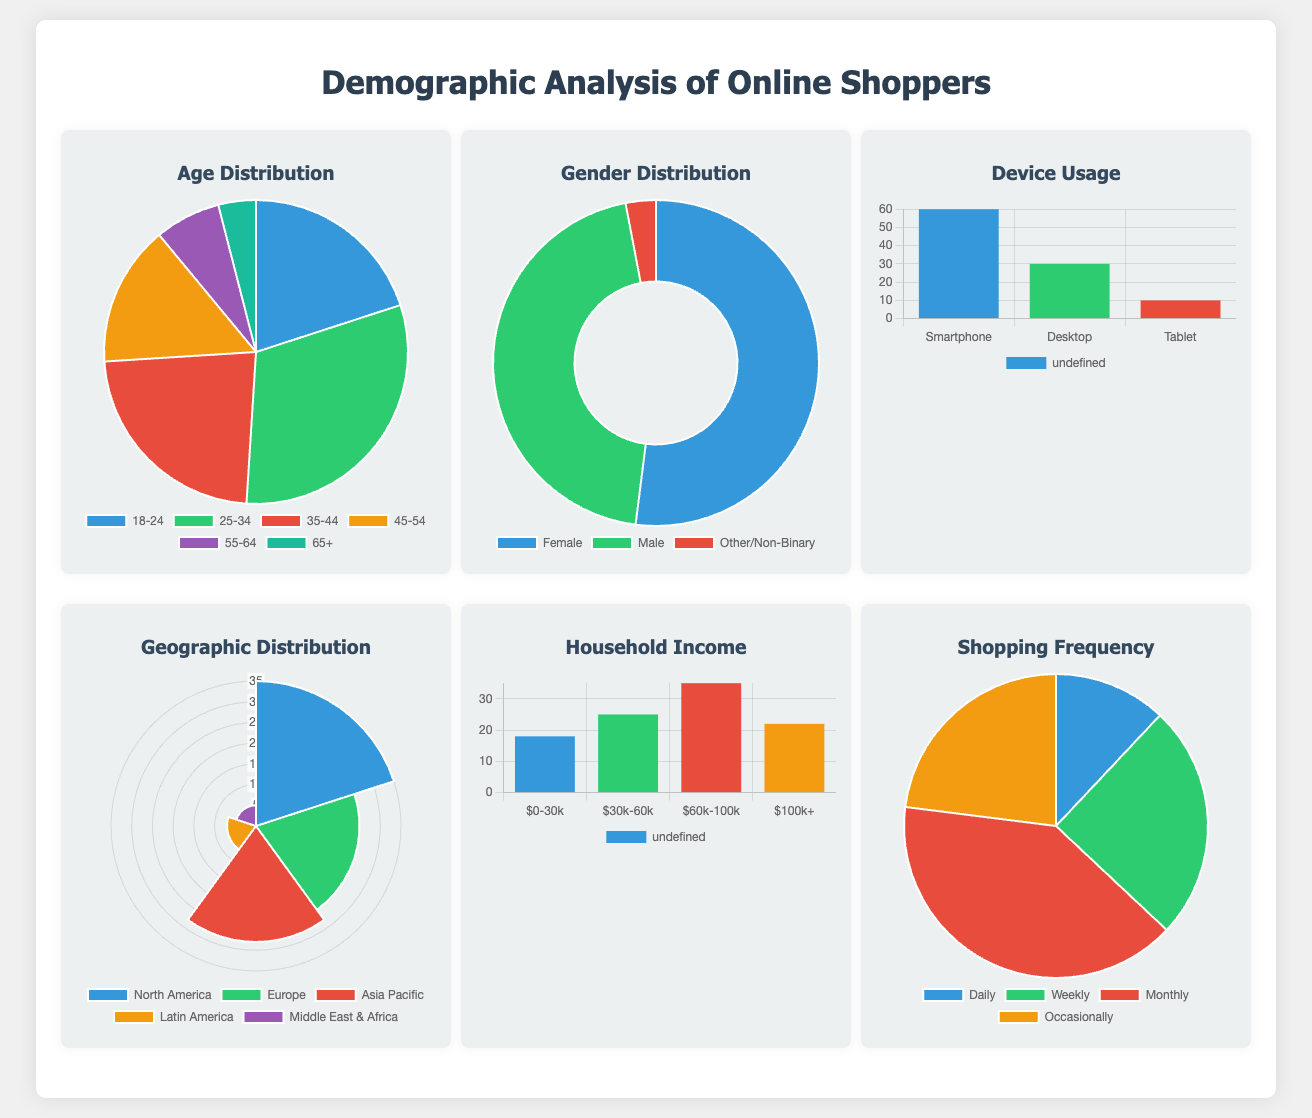What is the age group with the highest percentage of online shoppers? According to the Age Distribution chart, the age group 25-34 has the highest percentage, which is 31%.
Answer: 25-34 What percentage of online shoppers are female? The Gender Distribution chart shows that 52% of online shoppers identify as female.
Answer: 52% Which device is used by the most online shoppers? The Device Usage chart indicates that 60% of online shoppers use smartphones.
Answer: Smartphone What is the percentage of online shoppers from Latin America? The Geographic Distribution chart shows that 7% of online shoppers are from Latin America.
Answer: 7% What is the highest household income range of online shoppers? The Household Income chart indicates that the highest income range is between $60k-100k, with 35%.
Answer: $60k-100k How frequently do online shoppers shop weekly? The Shopping Frequency chart shows that 25% of online shoppers shop weekly.
Answer: 25% Which age group has the least representation among online shoppers? The Age Distribution chart reveals that the 65+ age group has the least representation at 4%.
Answer: 65+ What is the percentage of online shoppers who use tablets? The Device Usage chart shows that 10% of online shoppers use tablets.
Answer: 10% What demographic category contains the smallest proportion of shoppers? The Gender Distribution chart displays that Other/Non-Binary comprises the smallest proportion at 3%.
Answer: Other/Non-Binary 